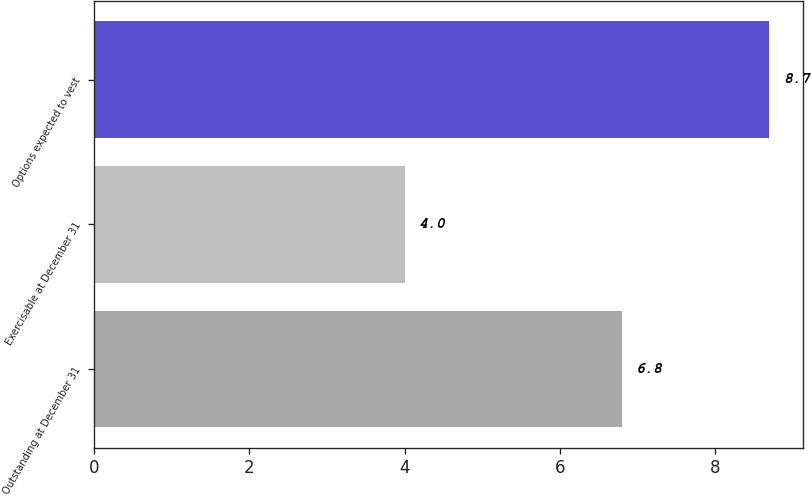Convert chart. <chart><loc_0><loc_0><loc_500><loc_500><bar_chart><fcel>Outstanding at December 31<fcel>Exercisable at December 31<fcel>Options expected to vest<nl><fcel>6.8<fcel>4<fcel>8.7<nl></chart> 